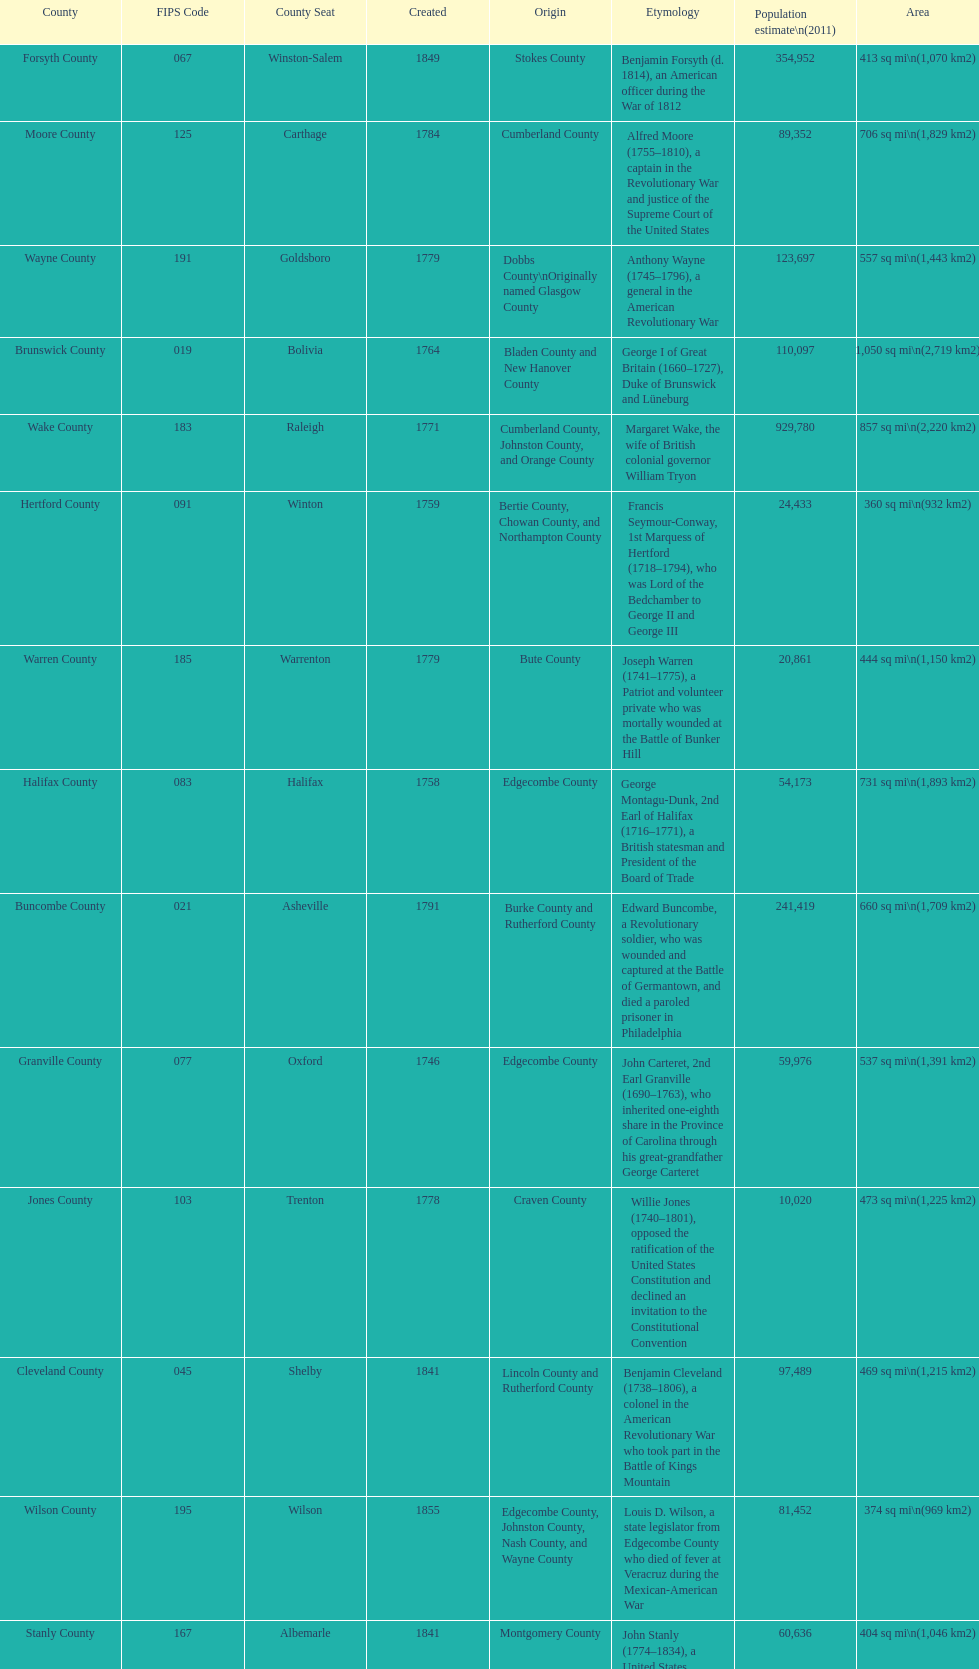Which county covers the most area? Dare County. 